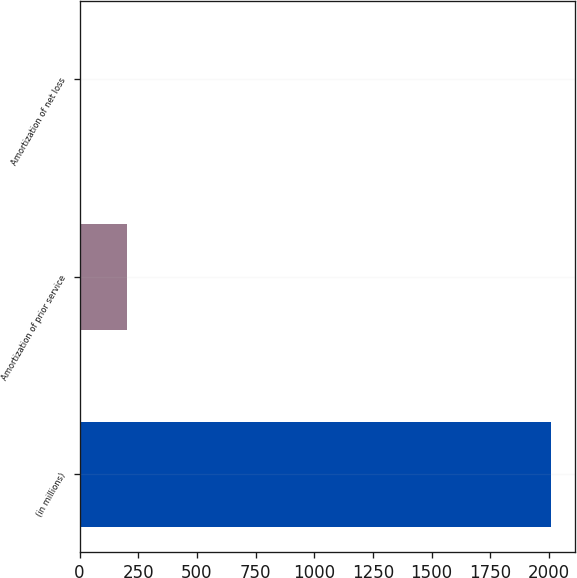Convert chart. <chart><loc_0><loc_0><loc_500><loc_500><bar_chart><fcel>(in millions)<fcel>Amortization of prior service<fcel>Amortization of net loss<nl><fcel>2010<fcel>201.9<fcel>1<nl></chart> 